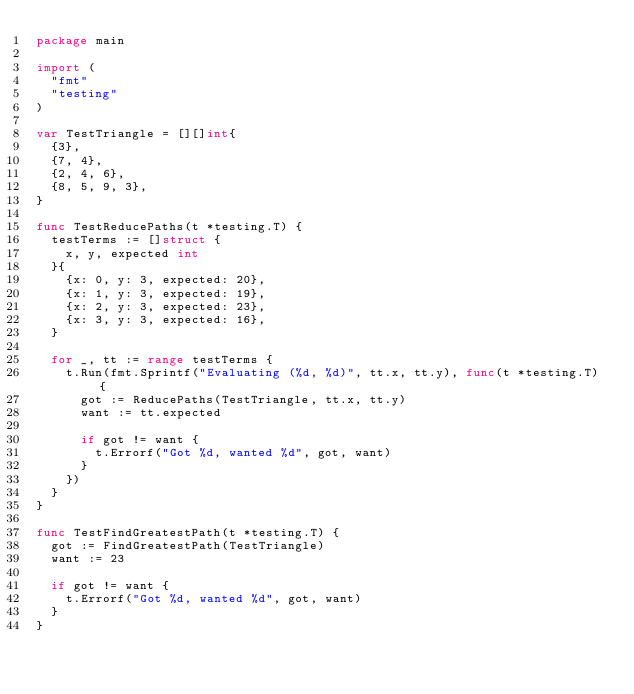<code> <loc_0><loc_0><loc_500><loc_500><_Go_>package main

import (
	"fmt"
	"testing"
)

var TestTriangle = [][]int{
	{3},
	{7, 4},
	{2, 4, 6},
	{8, 5, 9, 3},
}

func TestReducePaths(t *testing.T) {
	testTerms := []struct {
		x, y, expected int
	}{
		{x: 0, y: 3, expected: 20},
		{x: 1, y: 3, expected: 19},
		{x: 2, y: 3, expected: 23},
		{x: 3, y: 3, expected: 16},
	}

	for _, tt := range testTerms {
		t.Run(fmt.Sprintf("Evaluating (%d, %d)", tt.x, tt.y), func(t *testing.T) {
			got := ReducePaths(TestTriangle, tt.x, tt.y)
			want := tt.expected

			if got != want {
				t.Errorf("Got %d, wanted %d", got, want)
			}
		})
	}
}

func TestFindGreatestPath(t *testing.T) {
	got := FindGreatestPath(TestTriangle)
	want := 23

	if got != want {
		t.Errorf("Got %d, wanted %d", got, want)
	}
}
</code> 